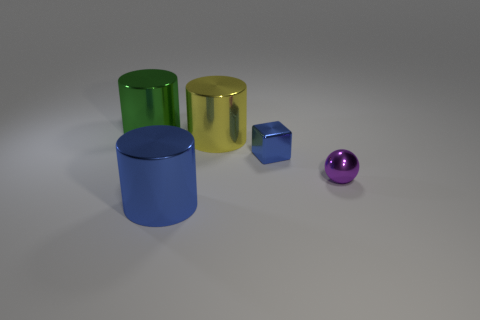There is a object that is the same color as the metal cube; what is its material?
Provide a short and direct response. Metal. There is a blue metal object that is in front of the tiny sphere; does it have the same shape as the green object?
Offer a terse response. Yes. There is a metal cylinder on the left side of the big cylinder in front of the small purple metallic object; are there any cylinders that are on the right side of it?
Offer a very short reply. Yes. How many other objects are the same shape as the purple metal object?
Provide a succinct answer. 0. There is a small object that is behind the tiny metal thing right of the small metal thing that is on the left side of the ball; what color is it?
Your response must be concise. Blue. What number of metallic cylinders are there?
Provide a short and direct response. 3. How many tiny things are either blue metallic cylinders or yellow cylinders?
Ensure brevity in your answer.  0. The other object that is the same size as the purple metallic thing is what shape?
Ensure brevity in your answer.  Cube. Is there anything else that is the same size as the green metal cylinder?
Provide a short and direct response. Yes. The blue thing that is in front of the tiny thing behind the small purple object is made of what material?
Provide a short and direct response. Metal. 